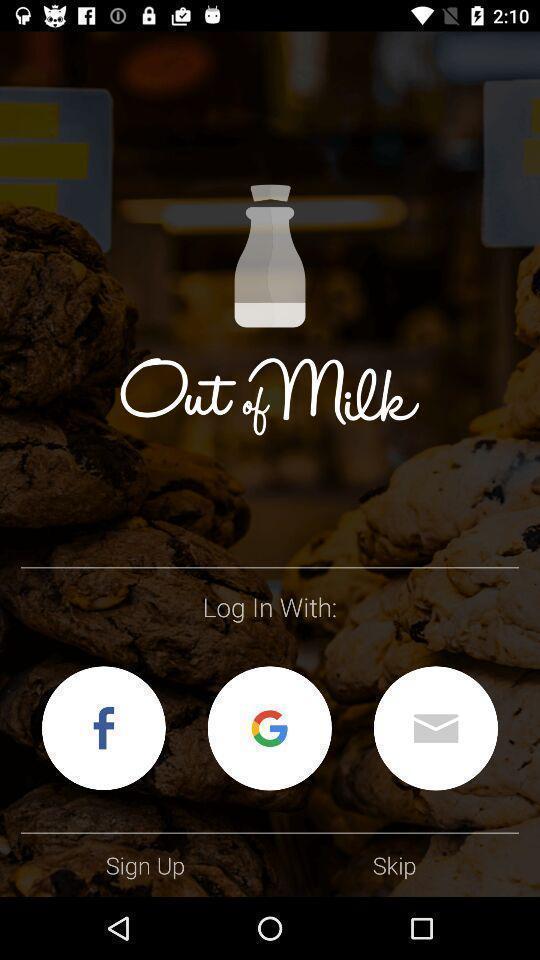What details can you identify in this image? Welcome page. 